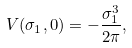Convert formula to latex. <formula><loc_0><loc_0><loc_500><loc_500>V ( \sigma _ { 1 } , 0 ) = - \frac { \sigma _ { 1 } ^ { 3 } } { 2 \pi } ,</formula> 